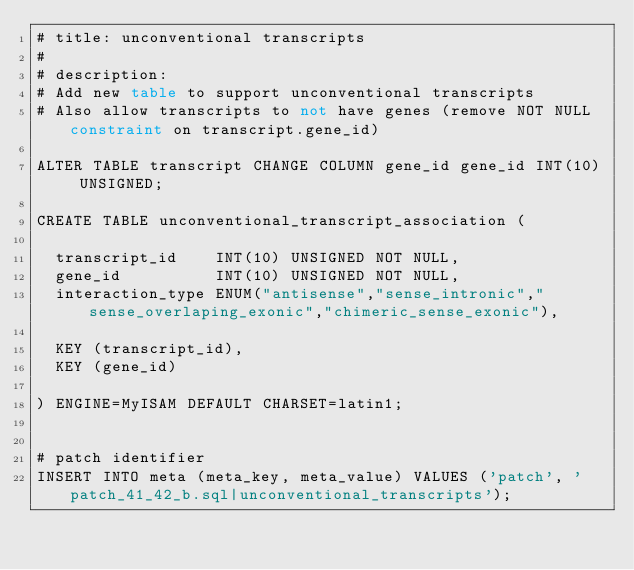Convert code to text. <code><loc_0><loc_0><loc_500><loc_500><_SQL_># title: unconventional transcripts
#
# description:
# Add new table to support unconventional transcripts
# Also allow transcripts to not have genes (remove NOT NULL constraint on transcript.gene_id)

ALTER TABLE transcript CHANGE COLUMN gene_id gene_id INT(10) UNSIGNED;

CREATE TABLE unconventional_transcript_association (

  transcript_id    INT(10) UNSIGNED NOT NULL,
  gene_id          INT(10) UNSIGNED NOT NULL,
  interaction_type ENUM("antisense","sense_intronic","sense_overlaping_exonic","chimeric_sense_exonic"),

  KEY (transcript_id),
  KEY (gene_id)

) ENGINE=MyISAM DEFAULT CHARSET=latin1;


# patch identifier
INSERT INTO meta (meta_key, meta_value) VALUES ('patch', 'patch_41_42_b.sql|unconventional_transcripts');</code> 